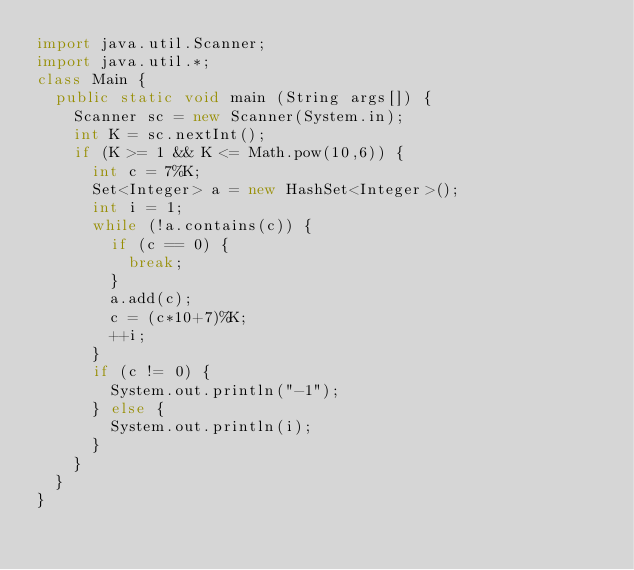<code> <loc_0><loc_0><loc_500><loc_500><_Java_>import java.util.Scanner;
import java.util.*;
class Main {
  public static void main (String args[]) {
    Scanner sc = new Scanner(System.in);
    int K = sc.nextInt();
    if (K >= 1 && K <= Math.pow(10,6)) {
      int c = 7%K;
      Set<Integer> a = new HashSet<Integer>();
      int i = 1;
      while (!a.contains(c)) {
        if (c == 0) {
          break;
        }
        a.add(c);
        c = (c*10+7)%K;
        ++i;
      }
      if (c != 0) {
        System.out.println("-1");
      } else {
        System.out.println(i);
      }
    }
  }
}</code> 